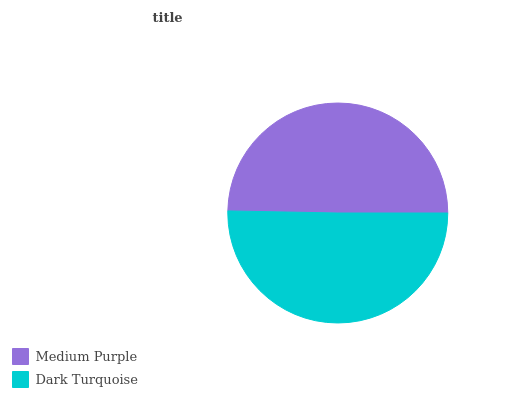Is Medium Purple the minimum?
Answer yes or no. Yes. Is Dark Turquoise the maximum?
Answer yes or no. Yes. Is Dark Turquoise the minimum?
Answer yes or no. No. Is Dark Turquoise greater than Medium Purple?
Answer yes or no. Yes. Is Medium Purple less than Dark Turquoise?
Answer yes or no. Yes. Is Medium Purple greater than Dark Turquoise?
Answer yes or no. No. Is Dark Turquoise less than Medium Purple?
Answer yes or no. No. Is Dark Turquoise the high median?
Answer yes or no. Yes. Is Medium Purple the low median?
Answer yes or no. Yes. Is Medium Purple the high median?
Answer yes or no. No. Is Dark Turquoise the low median?
Answer yes or no. No. 